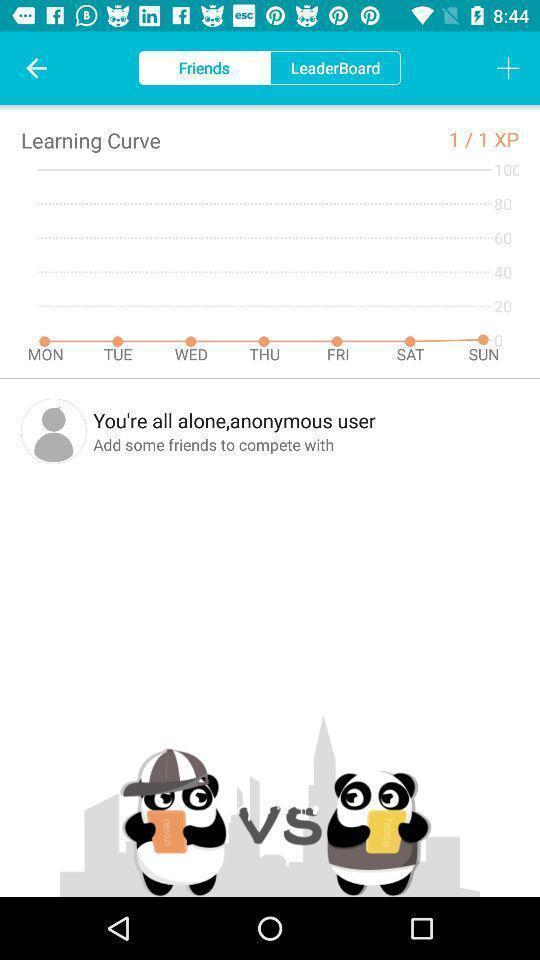Describe the visual elements of this screenshot. Screen displaying the friends page. 